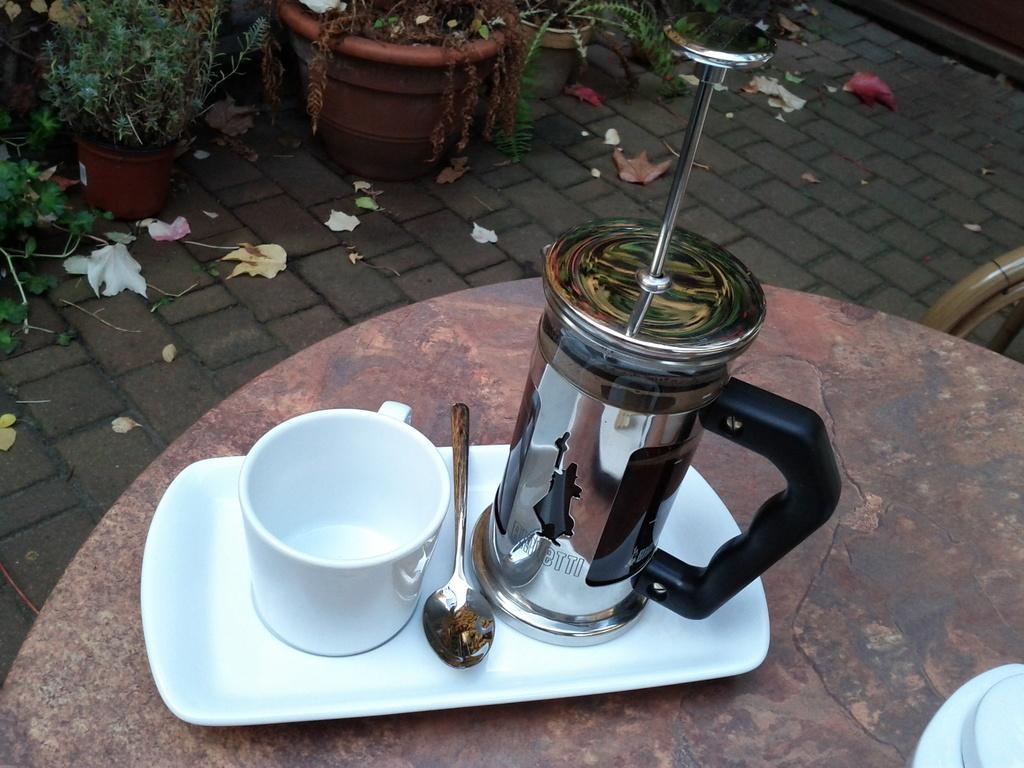Describe this image in one or two sentences. There is a table. On that there is a tray. On that there is a cup, spoon and a jar. In the back there are pots with plants on the floor. 